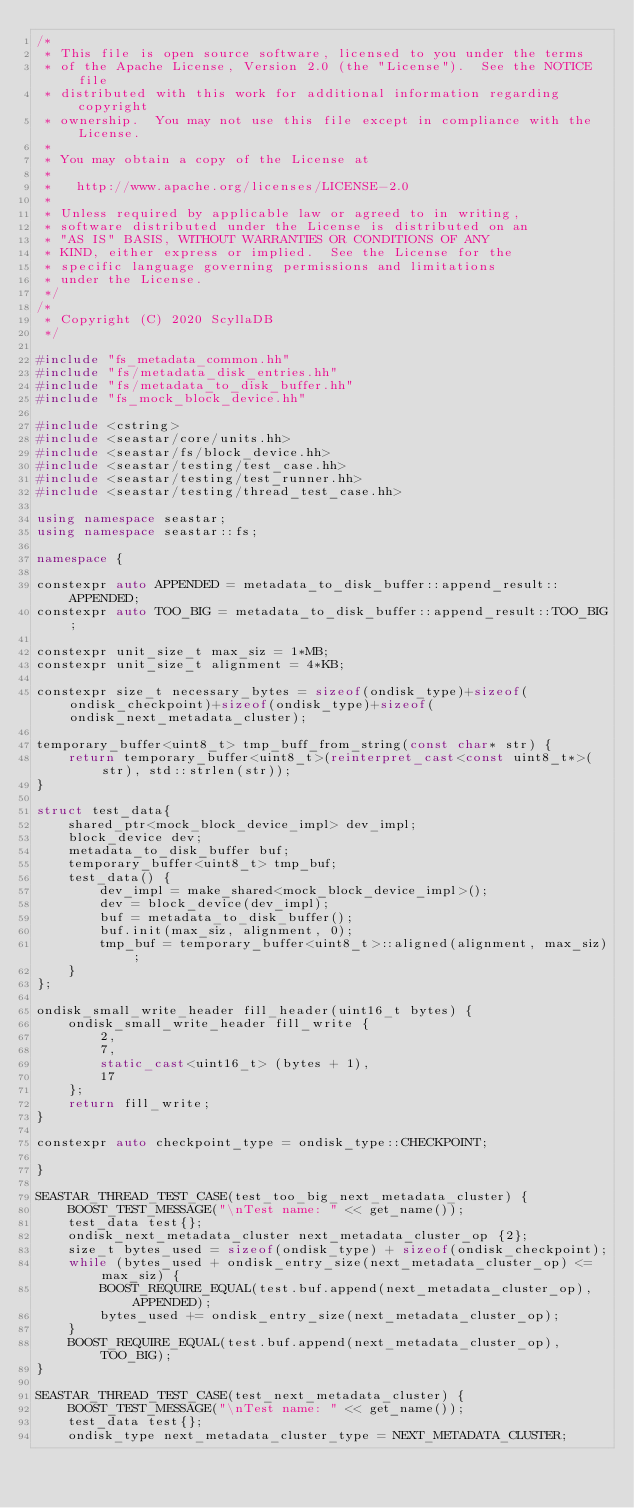<code> <loc_0><loc_0><loc_500><loc_500><_C++_>/*
 * This file is open source software, licensed to you under the terms
 * of the Apache License, Version 2.0 (the "License").  See the NOTICE file
 * distributed with this work for additional information regarding copyright
 * ownership.  You may not use this file except in compliance with the License.
 *
 * You may obtain a copy of the License at
 *
 *   http://www.apache.org/licenses/LICENSE-2.0
 *
 * Unless required by applicable law or agreed to in writing,
 * software distributed under the License is distributed on an
 * "AS IS" BASIS, WITHOUT WARRANTIES OR CONDITIONS OF ANY
 * KIND, either express or implied.  See the License for the
 * specific language governing permissions and limitations
 * under the License.
 */
/*
 * Copyright (C) 2020 ScyllaDB
 */

#include "fs_metadata_common.hh"
#include "fs/metadata_disk_entries.hh"
#include "fs/metadata_to_disk_buffer.hh"
#include "fs_mock_block_device.hh"

#include <cstring>
#include <seastar/core/units.hh>
#include <seastar/fs/block_device.hh>
#include <seastar/testing/test_case.hh>
#include <seastar/testing/test_runner.hh>
#include <seastar/testing/thread_test_case.hh>

using namespace seastar;
using namespace seastar::fs;

namespace {

constexpr auto APPENDED = metadata_to_disk_buffer::append_result::APPENDED;
constexpr auto TOO_BIG = metadata_to_disk_buffer::append_result::TOO_BIG;

constexpr unit_size_t max_siz = 1*MB;
constexpr unit_size_t alignment = 4*KB;

constexpr size_t necessary_bytes = sizeof(ondisk_type)+sizeof(ondisk_checkpoint)+sizeof(ondisk_type)+sizeof(ondisk_next_metadata_cluster);

temporary_buffer<uint8_t> tmp_buff_from_string(const char* str) {
    return temporary_buffer<uint8_t>(reinterpret_cast<const uint8_t*>(str), std::strlen(str));
}

struct test_data{
    shared_ptr<mock_block_device_impl> dev_impl;
    block_device dev;
    metadata_to_disk_buffer buf;
    temporary_buffer<uint8_t> tmp_buf;
    test_data() {
        dev_impl = make_shared<mock_block_device_impl>();
        dev = block_device(dev_impl);
        buf = metadata_to_disk_buffer();
        buf.init(max_siz, alignment, 0);
        tmp_buf = temporary_buffer<uint8_t>::aligned(alignment, max_siz);
    }
};

ondisk_small_write_header fill_header(uint16_t bytes) {
    ondisk_small_write_header fill_write {
        2,
        7,
        static_cast<uint16_t> (bytes + 1),
        17
    };
    return fill_write;
}

constexpr auto checkpoint_type = ondisk_type::CHECKPOINT;

}

SEASTAR_THREAD_TEST_CASE(test_too_big_next_metadata_cluster) {
    BOOST_TEST_MESSAGE("\nTest name: " << get_name());
    test_data test{};
    ondisk_next_metadata_cluster next_metadata_cluster_op {2};
    size_t bytes_used = sizeof(ondisk_type) + sizeof(ondisk_checkpoint);
    while (bytes_used + ondisk_entry_size(next_metadata_cluster_op) <= max_siz) {
        BOOST_REQUIRE_EQUAL(test.buf.append(next_metadata_cluster_op), APPENDED);
        bytes_used += ondisk_entry_size(next_metadata_cluster_op);
    }
    BOOST_REQUIRE_EQUAL(test.buf.append(next_metadata_cluster_op), TOO_BIG);
}

SEASTAR_THREAD_TEST_CASE(test_next_metadata_cluster) {
    BOOST_TEST_MESSAGE("\nTest name: " << get_name());
    test_data test{};
    ondisk_type next_metadata_cluster_type = NEXT_METADATA_CLUSTER;</code> 